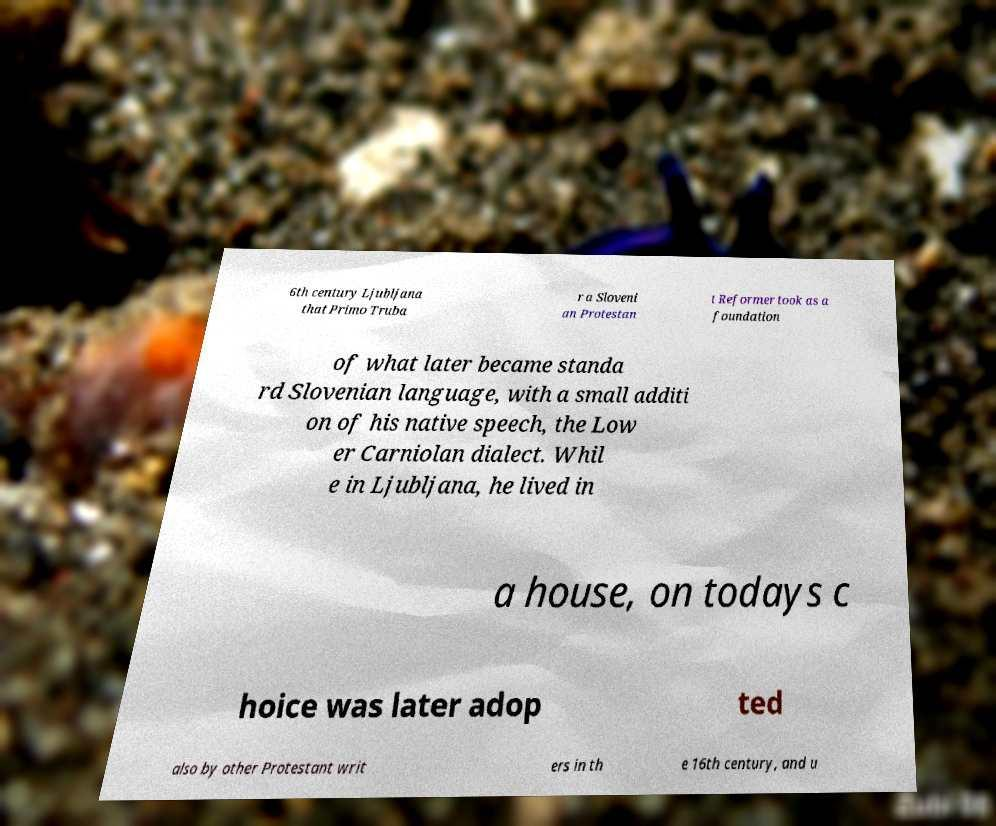Please identify and transcribe the text found in this image. 6th century Ljubljana that Primo Truba r a Sloveni an Protestan t Reformer took as a foundation of what later became standa rd Slovenian language, with a small additi on of his native speech, the Low er Carniolan dialect. Whil e in Ljubljana, he lived in a house, on todays c hoice was later adop ted also by other Protestant writ ers in th e 16th century, and u 